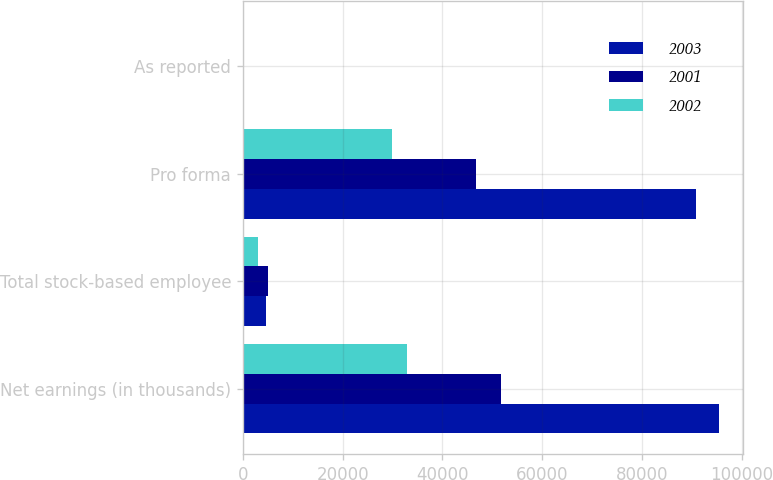Convert chart. <chart><loc_0><loc_0><loc_500><loc_500><stacked_bar_chart><ecel><fcel>Net earnings (in thousands)<fcel>Total stock-based employee<fcel>Pro forma<fcel>As reported<nl><fcel>2003<fcel>95459<fcel>4642<fcel>90817<fcel>1.2<nl><fcel>2001<fcel>51816<fcel>5008<fcel>46808<fcel>0.68<nl><fcel>2002<fcel>32945<fcel>3083<fcel>29862<fcel>0.46<nl></chart> 